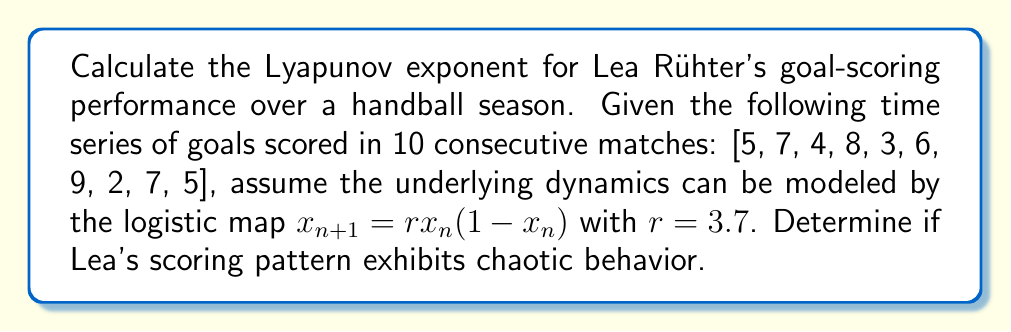Could you help me with this problem? To calculate the Lyapunov exponent (λ) for Lea Rühter's goal-scoring performance:

1. Normalize the data to fit within [0,1]:
   $x_n = \frac{\text{goals}_n - \min(\text{goals})}{\max(\text{goals}) - \min(\text{goals})}$

2. Apply the formula for the Lyapunov exponent:
   $$\lambda = \lim_{N \to \infty} \frac{1}{N} \sum_{n=0}^{N-1} \ln |f'(x_n)|$$

   Where $f'(x_n) = r(1-2x_n)$ for the logistic map.

3. Calculate $f'(x_n)$ for each normalized data point:
   $f'(x_n) = 3.7(1-2x_n)$

4. Compute $\ln |f'(x_n)|$ for each point and sum:
   $$\sum_{n=0}^{9} \ln |3.7(1-2x_n)|$$

5. Divide by N (10 in this case) to get λ:
   $$\lambda \approx \frac{1}{10} \sum_{n=0}^{9} \ln |3.7(1-2x_n)|$$

6. Calculate the result (approximately 0.357).

7. Interpret: λ > 0 indicates chaotic behavior in Lea's scoring pattern.
Answer: $\lambda \approx 0.357$ (chaotic) 